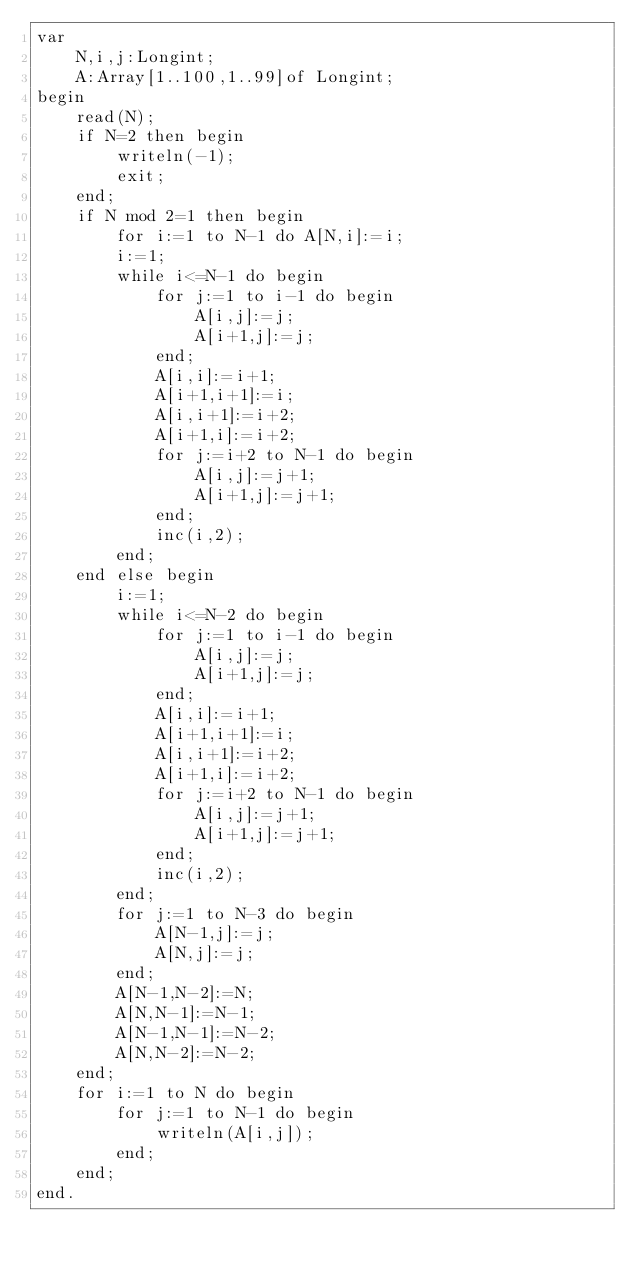Convert code to text. <code><loc_0><loc_0><loc_500><loc_500><_Pascal_>var
	N,i,j:Longint;
	A:Array[1..100,1..99]of Longint;
begin
	read(N);
	if N=2 then begin
		writeln(-1);
		exit;
	end;
	if N mod 2=1 then begin
		for i:=1 to N-1 do A[N,i]:=i;
		i:=1;
		while i<=N-1 do begin
			for j:=1 to i-1 do begin
				A[i,j]:=j;
				A[i+1,j]:=j;
			end;
			A[i,i]:=i+1;
			A[i+1,i+1]:=i;
			A[i,i+1]:=i+2;
			A[i+1,i]:=i+2;
			for j:=i+2 to N-1 do begin
				A[i,j]:=j+1;
				A[i+1,j]:=j+1;
			end;
			inc(i,2);
		end;
	end else begin
		i:=1;
		while i<=N-2 do begin
			for j:=1 to i-1 do begin
				A[i,j]:=j;
				A[i+1,j]:=j;
			end;
			A[i,i]:=i+1;
			A[i+1,i+1]:=i;
			A[i,i+1]:=i+2;
			A[i+1,i]:=i+2;
			for j:=i+2 to N-1 do begin
				A[i,j]:=j+1;
				A[i+1,j]:=j+1;
			end;
			inc(i,2);
		end;
		for j:=1 to N-3 do begin
			A[N-1,j]:=j;
			A[N,j]:=j;
		end;
		A[N-1,N-2]:=N;
		A[N,N-1]:=N-1;
		A[N-1,N-1]:=N-2;
		A[N,N-2]:=N-2;
	end;
	for i:=1 to N do begin
		for j:=1 to N-1 do begin
			writeln(A[i,j]);
		end;
	end;
end.
</code> 